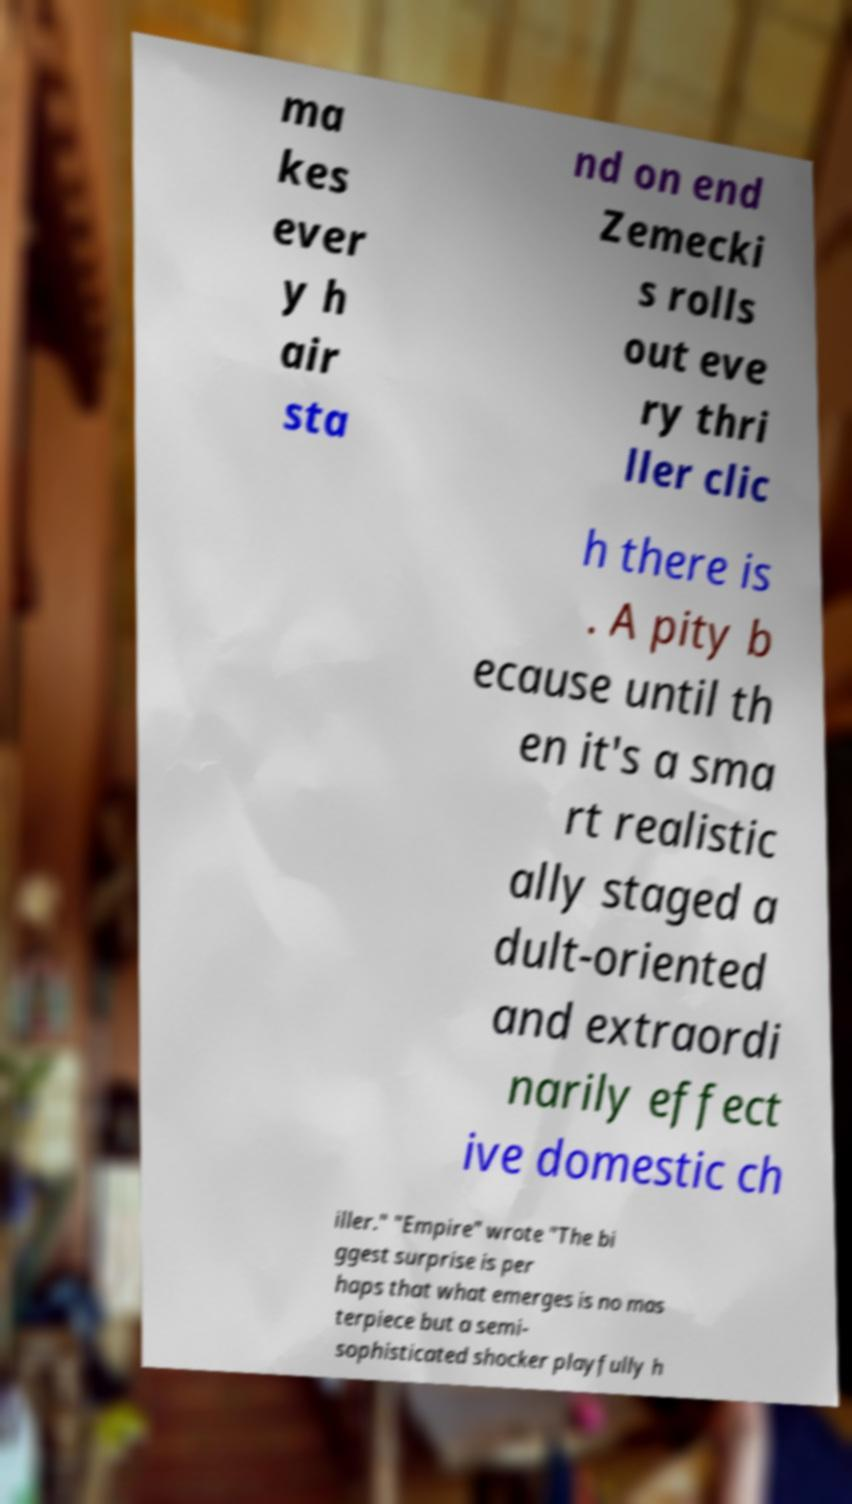I need the written content from this picture converted into text. Can you do that? ma kes ever y h air sta nd on end Zemecki s rolls out eve ry thri ller clic h there is . A pity b ecause until th en it's a sma rt realistic ally staged a dult-oriented and extraordi narily effect ive domestic ch iller." "Empire" wrote "The bi ggest surprise is per haps that what emerges is no mas terpiece but a semi- sophisticated shocker playfully h 